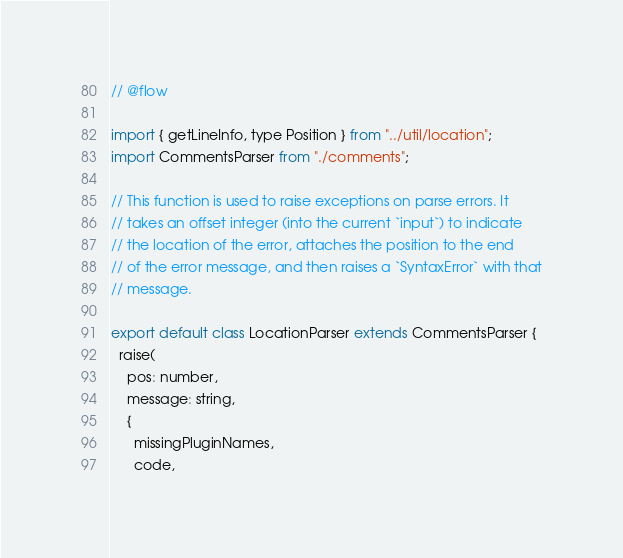Convert code to text. <code><loc_0><loc_0><loc_500><loc_500><_JavaScript_>// @flow

import { getLineInfo, type Position } from "../util/location";
import CommentsParser from "./comments";

// This function is used to raise exceptions on parse errors. It
// takes an offset integer (into the current `input`) to indicate
// the location of the error, attaches the position to the end
// of the error message, and then raises a `SyntaxError` with that
// message.

export default class LocationParser extends CommentsParser {
  raise(
    pos: number,
    message: string,
    {
      missingPluginNames,
      code,</code> 